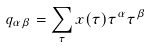<formula> <loc_0><loc_0><loc_500><loc_500>q _ { \alpha \beta } = \sum _ { \tau } x ( \tau ) \tau ^ { \alpha } \tau ^ { \beta }</formula> 